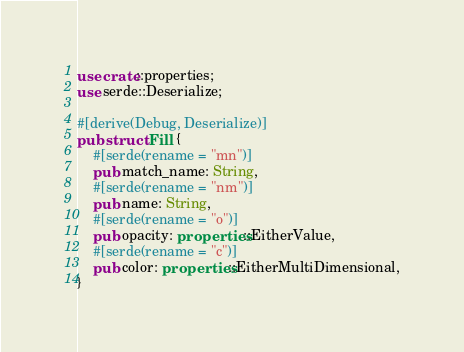<code> <loc_0><loc_0><loc_500><loc_500><_Rust_>use crate::properties;
use serde::Deserialize;

#[derive(Debug, Deserialize)]
pub struct Fill {
    #[serde(rename = "mn")]
    pub match_name: String,
    #[serde(rename = "nm")]
    pub name: String,
    #[serde(rename = "o")]
    pub opacity: properties::EitherValue,
    #[serde(rename = "c")]
    pub color: properties::EitherMultiDimensional,
}
</code> 